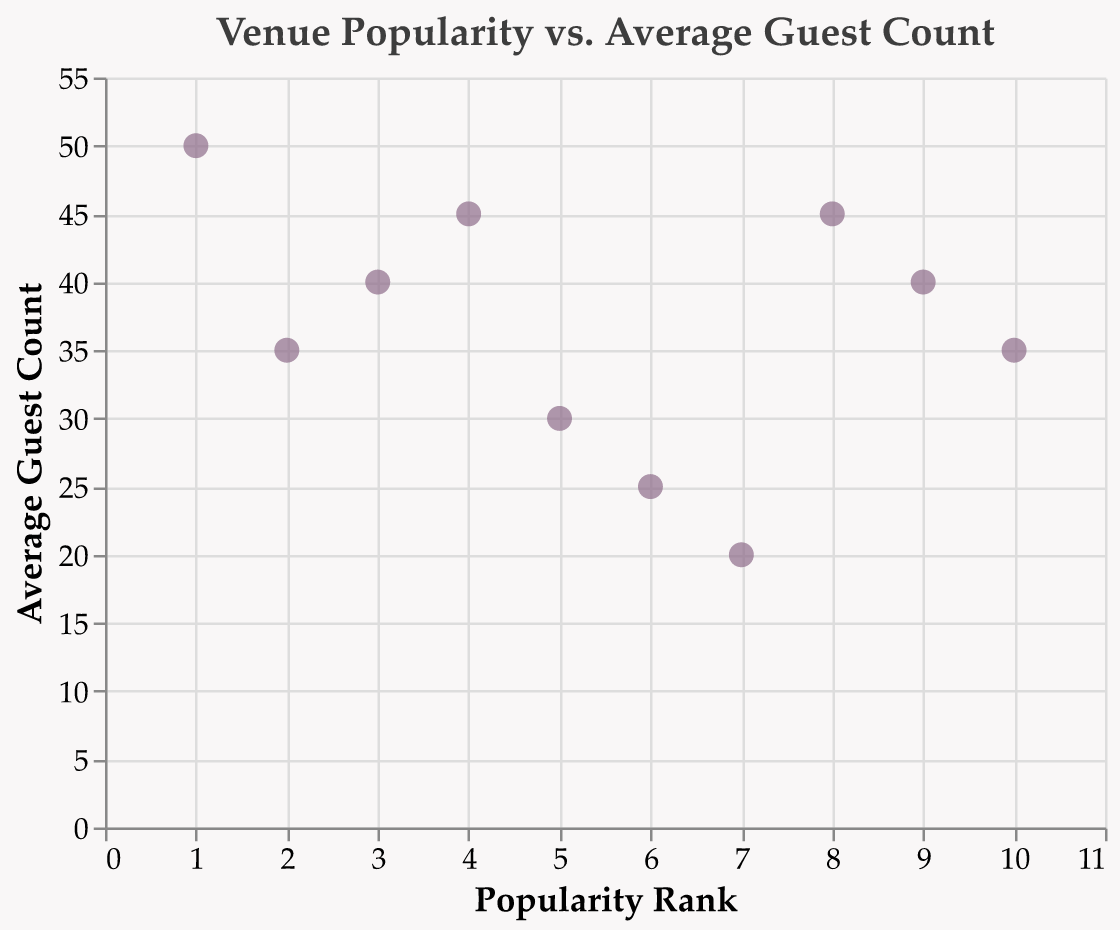What is the title of the scatter plot? The title of the scatter plot is displayed prominently at the top of the chart.
Answer: Venue Popularity vs. Average Guest Count How many venues have an average guest count of 45? By observing the y-axis and looking for the data points that align with the value 45, we can count the number of points at this level.
Answer: 2 Which venue has the lowest average guest count? By identifying the smallest value on the y-axis and finding the corresponding venue in the tooltip, we can determine the venue with the lowest average guest count.
Answer: The Ivy Rose Barn What is the average guest count at The Enchanted Barn? By hovering over the data point representing The Enchanted Barn or checking the figure, we can find its average guest count.
Answer: 50 Which venue is more popular, Garrison Gardens or Serenbe? By comparing the Popularity Rank values on the x-axis for both Garrison Gardens and Serenbe, we can see which has a smaller number (higher rank).
Answer: Garrison Gardens What's the difference in average guest count between The Little Nell and Saddle Woods Farm? Find the average guest count for both The Little Nell (35) and Saddle Woods Farm (40) from the y-axis and subtract the smaller value from the larger one (40 - 35 = 5).
Answer: 5 How many venues have an average guest count of less than 25? Count the data points that have a value below 25 on the y-axis.
Answer: 1 What is the average guest count for venues with a popularity rank lower than 5? Sum the average guest counts for venues with a popularity rank of 1, 2, 3, and 4, and then divide by 4. Calculations: (50 + 35 + 40 + 45)/4 = 170/4 = 42.5.
Answer: 42.5 Compare the popularity rank of The Foundry and The Enchanted Barn. Which is higher? Check the x-axis for the Popularity Rank values of The Foundry (8) and The Enchanted Barn (1), and compare which number is smaller (higher ranking).
Answer: The Enchanted Barn What is the median average guest count of all venues? List the average guest counts in numerical order (20, 25, 30, 35, 35, 40, 40, 45, 45, 50) and find the middle value. Since we have an even number of values, average the 5th and 6th values: (35 + 40)/2 = 37.5.
Answer: 37.5 